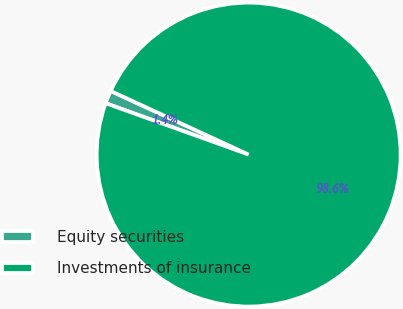<chart> <loc_0><loc_0><loc_500><loc_500><pie_chart><fcel>Equity securities<fcel>Investments of insurance<nl><fcel>1.39%<fcel>98.61%<nl></chart> 